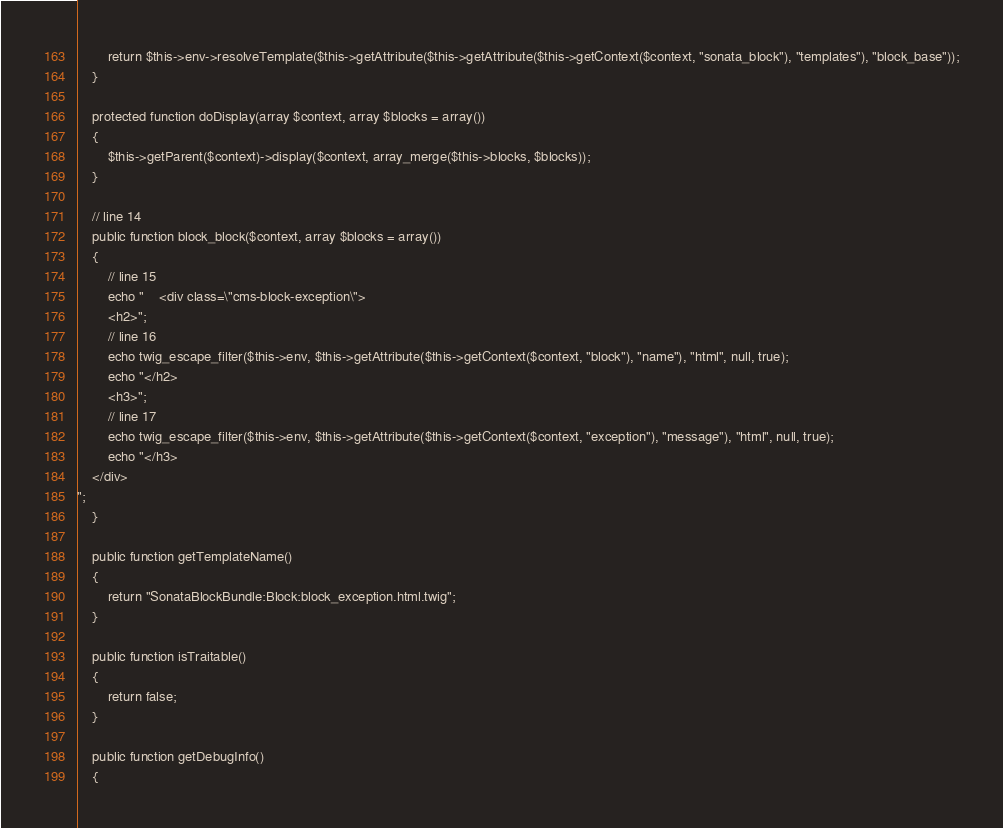Convert code to text. <code><loc_0><loc_0><loc_500><loc_500><_PHP_>        return $this->env->resolveTemplate($this->getAttribute($this->getAttribute($this->getContext($context, "sonata_block"), "templates"), "block_base"));
    }

    protected function doDisplay(array $context, array $blocks = array())
    {
        $this->getParent($context)->display($context, array_merge($this->blocks, $blocks));
    }

    // line 14
    public function block_block($context, array $blocks = array())
    {
        // line 15
        echo "    <div class=\"cms-block-exception\">
        <h2>";
        // line 16
        echo twig_escape_filter($this->env, $this->getAttribute($this->getContext($context, "block"), "name"), "html", null, true);
        echo "</h2>
        <h3>";
        // line 17
        echo twig_escape_filter($this->env, $this->getAttribute($this->getContext($context, "exception"), "message"), "html", null, true);
        echo "</h3>
    </div>
";
    }

    public function getTemplateName()
    {
        return "SonataBlockBundle:Block:block_exception.html.twig";
    }

    public function isTraitable()
    {
        return false;
    }

    public function getDebugInfo()
    {</code> 